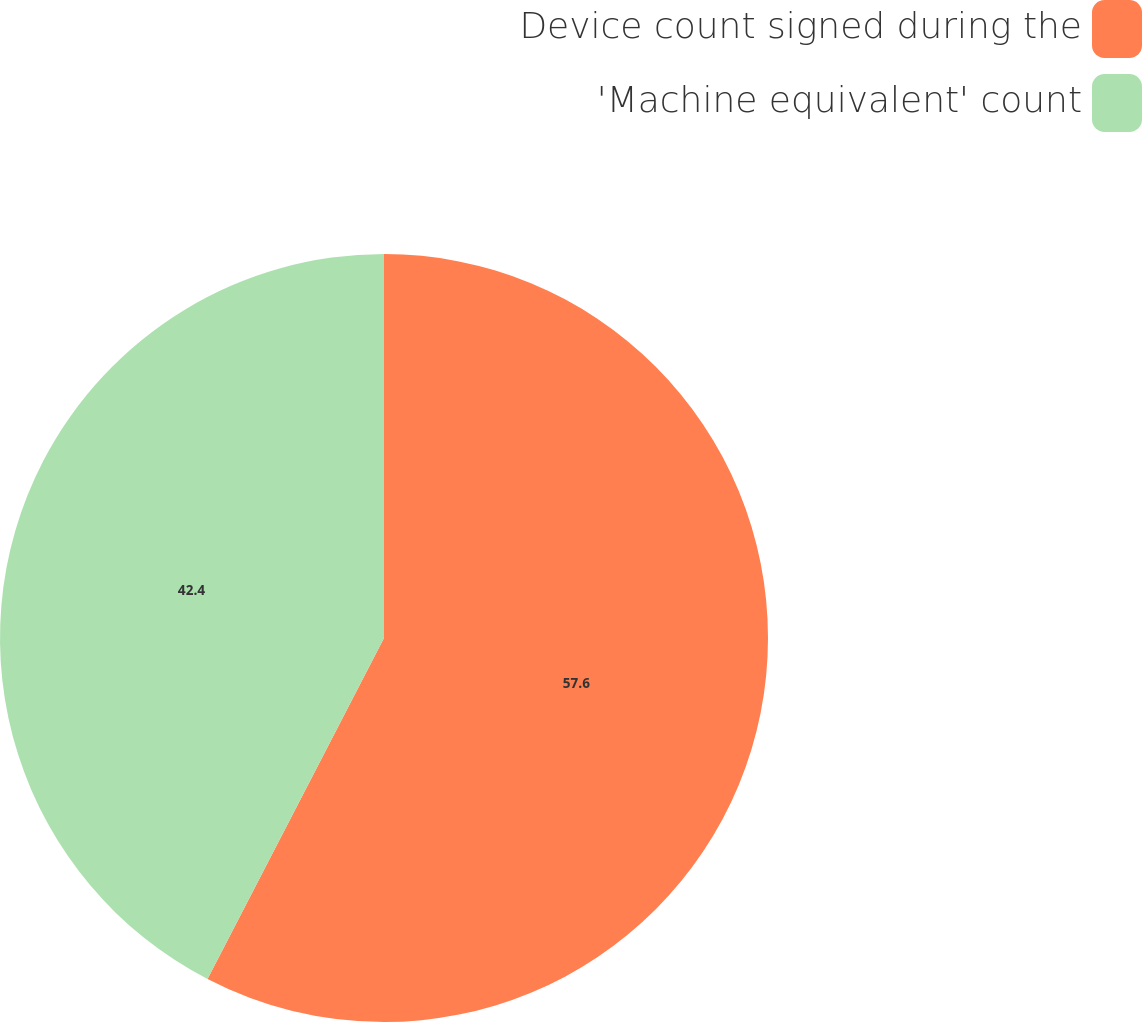<chart> <loc_0><loc_0><loc_500><loc_500><pie_chart><fcel>Device count signed during the<fcel>'Machine equivalent' count<nl><fcel>57.6%<fcel>42.4%<nl></chart> 